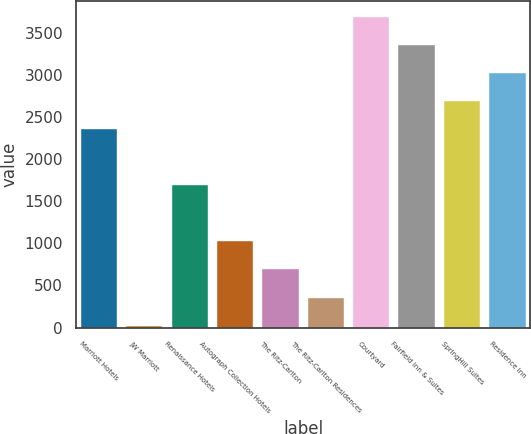Convert chart. <chart><loc_0><loc_0><loc_500><loc_500><bar_chart><fcel>Marriott Hotels<fcel>JW Marriott<fcel>Renaissance Hotels<fcel>Autograph Collection Hotels<fcel>The Ritz-Carlton<fcel>The Ritz-Carlton Residences<fcel>Courtyard<fcel>Fairfield Inn & Suites<fcel>SpringHill Suites<fcel>Residence Inn<nl><fcel>2357.5<fcel>23<fcel>1690.5<fcel>1023.5<fcel>690<fcel>356.5<fcel>3691.5<fcel>3358<fcel>2691<fcel>3024.5<nl></chart> 